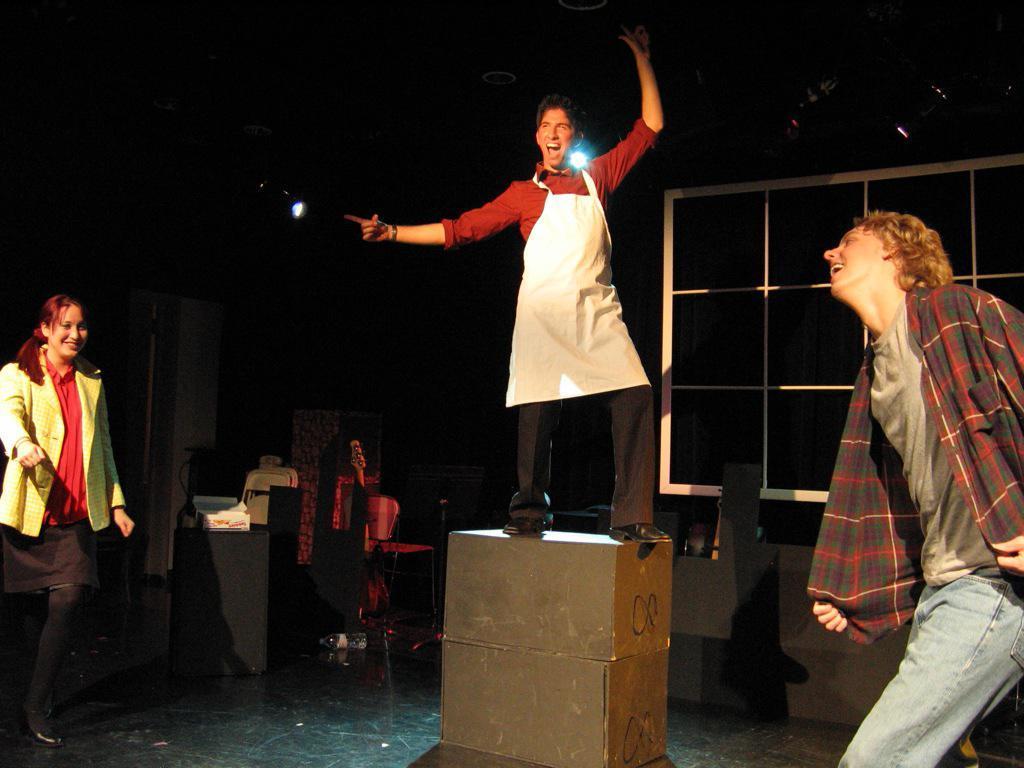Please provide a concise description of this image. This is an image clicked in the dark. Here I can see three persons. Two are men and one is woman. The man who is in the middle is standing on a box. It seems like these three people are dancing. In the background, I can see a table on which few objects are placed. On the top I can see the light. The background is in black color. 